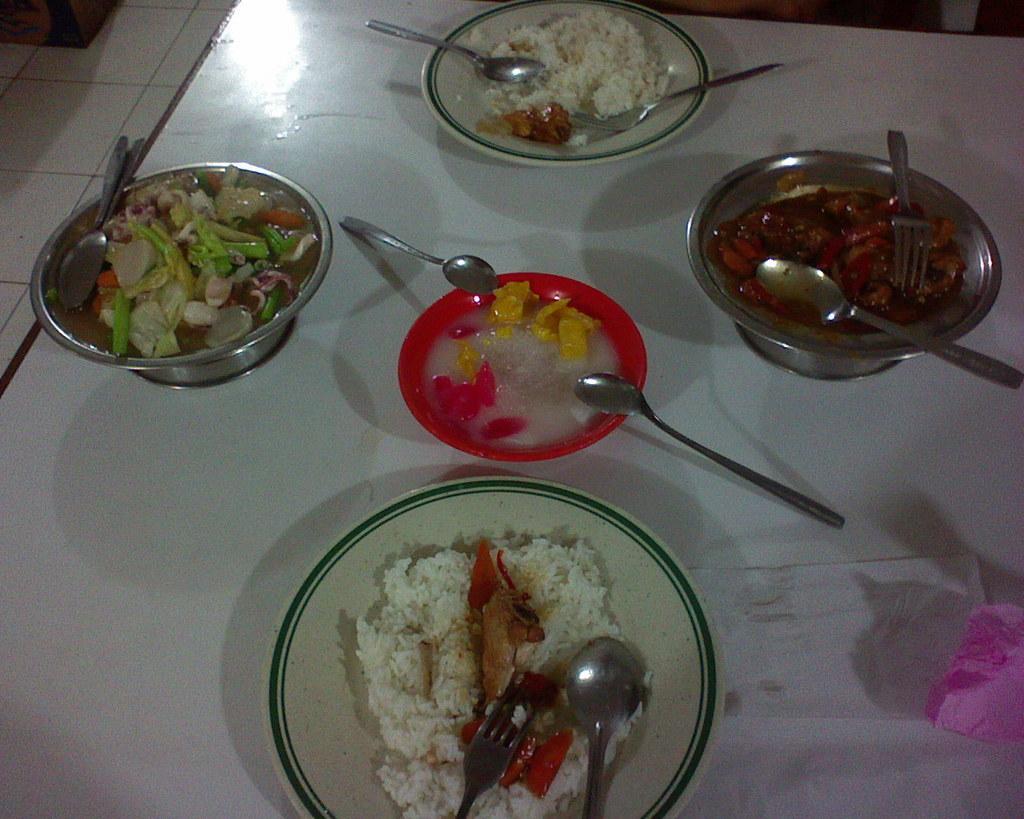Could you give a brief overview of what you see in this image? In this picture there is a dining table in the center of the image, there are bowls and spoons which contains food items in it. 